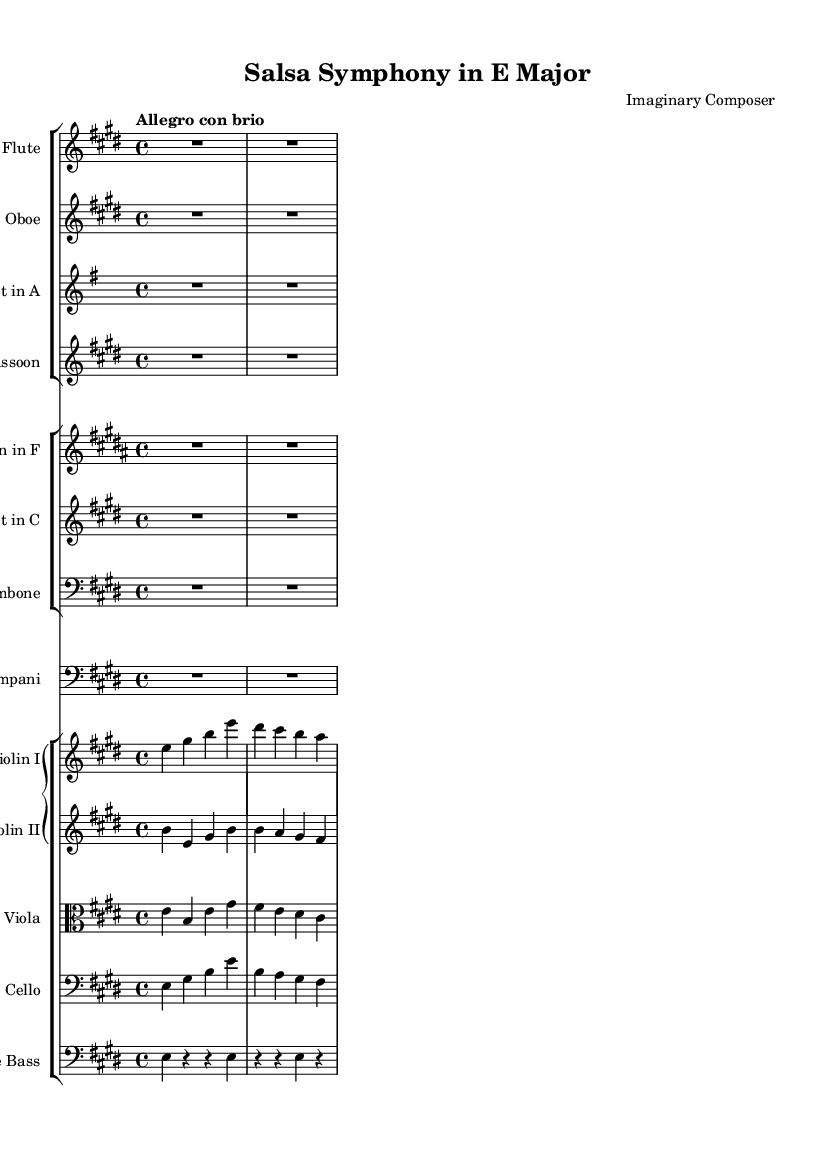What is the key signature of this music? The key signature indicates E major, which has four sharps: F#, C#, G#, and D#. This can be determined by looking at the key signature notation located at the beginning of the score.
Answer: E major What is the time signature of this music? The time signature is indicated as 4/4, meaning there are four beats per measure and a quarter note receives one beat. This is visible at the start of the score right after the key signature.
Answer: 4/4 What is the tempo marking of this music? The tempo marking is "Allegro con brio," which indicates a lively and brisk pace. This is found at the beginning of the piece, indicating the intended speed and character when performed.
Answer: Allegro con brio How many instruments are in the woodwind section? There are four instruments in the woodwind section: flute, oboe, clarinet, and bassoon. This can be deduced by counting the individual staff lines in the woodwind group at the top of the score.
Answer: Four Which movement likely features a dance rhythm? The title "Salsa Symphony" suggests that the movements would incorporate dance-like rhythms, particularly rhythmic patterns characteristic of salsa music. The lively tempo and potential rhythmic sections indicate this style.
Answer: Salsa What is the role of the timpani in this composition? The timpani typically provides rhythmic foundation and accentuation in orchestral works. Here, it appears within the score, and while it has a rest pattern, it likely plays significant accents during key moments to enhance the overall rhythm of the piece.
Answer: Rhythmic foundation What type of symphony is represented in this piece? This piece is a symphony that embodies dance-inspired movements, specifically styled after a salsa dance form. The lively character and instrumentation suggest it aligns with symphonic forms that integrate dance rhythms.
Answer: Dance-inspired symphony 